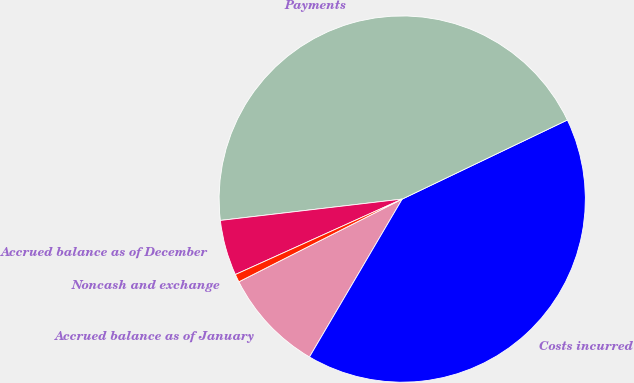Convert chart. <chart><loc_0><loc_0><loc_500><loc_500><pie_chart><fcel>Accrued balance as of January<fcel>Costs incurred<fcel>Payments<fcel>Accrued balance as of December<fcel>Noncash and exchange<nl><fcel>9.09%<fcel>40.56%<fcel>44.76%<fcel>4.9%<fcel>0.7%<nl></chart> 